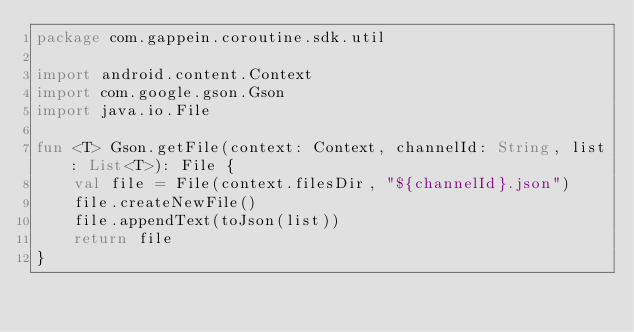Convert code to text. <code><loc_0><loc_0><loc_500><loc_500><_Kotlin_>package com.gappein.coroutine.sdk.util

import android.content.Context
import com.google.gson.Gson
import java.io.File

fun <T> Gson.getFile(context: Context, channelId: String, list: List<T>): File {
    val file = File(context.filesDir, "${channelId}.json")
    file.createNewFile()
    file.appendText(toJson(list))
    return file
}</code> 